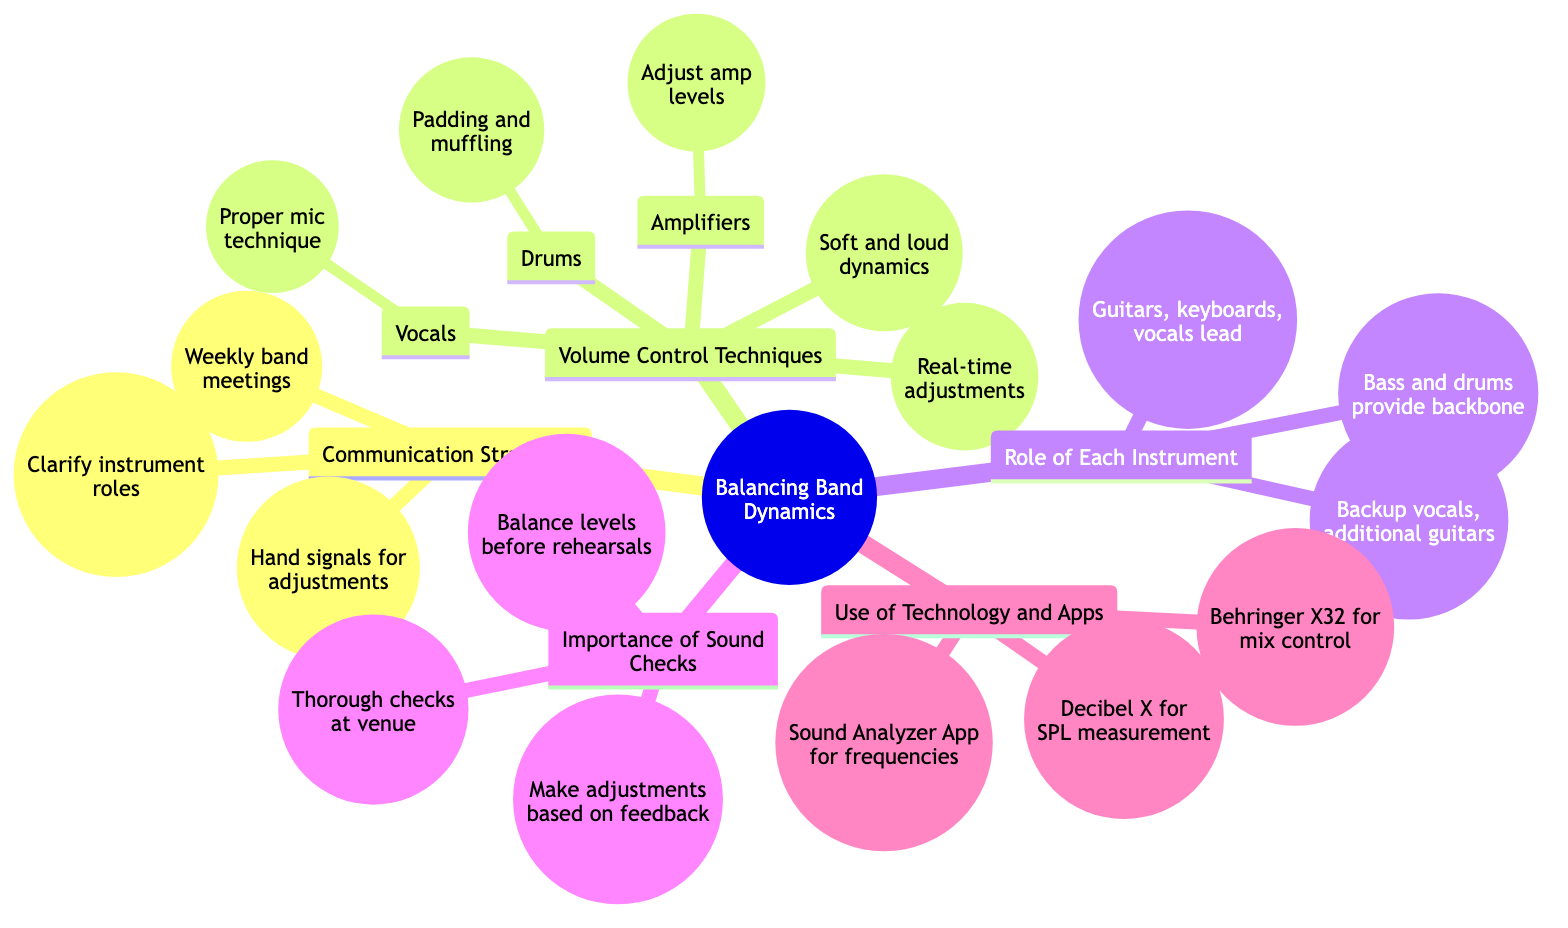What are the three main categories in the diagram? The main categories are 'Communication Strategies', 'Volume Control Techniques', 'Role of Each Instrument', 'Importance of Sound Checks', and 'Use of Technology and Apps'. Since the question asks for three, any three of the five will suffice.
Answer: Communication Strategies, Volume Control Techniques, Role of Each Instrument How many techniques are listed under Volume Control Techniques? Under 'Volume Control Techniques', there are four main techniques: 'Instrumental Adjustments', 'Use of Dynamics', 'Volume Pedals'. Therefore, the answer is three techniques.
Answer: 3 What is one method used for controlling drum volume? In the 'Instrumental Adjustments' section under 'Volume Control Techniques', 'Padding and muffling' is listed as a method for controlling drum volume.
Answer: Padding and muffling Which instrument is listed as part of the Rhythm Section? The 'Rhythm Section' includes 'Bass and drums' as part of its role in maintaining the groove.
Answer: Bass and drums What feedback mechanism is mentioned in the Importance of Sound Checks? The diagram mentions 'Feedback Loop' under 'Importance of Sound Checks', which indicates options for making adjustments based on sound checks.
Answer: Feedback Loop Name an app used for measuring sound pressure levels. Under 'Use of Technology and Apps for Volume Balancing', 'Decibel X' is mentioned as an app for measuring sound pressure levels.
Answer: Decibel X Which type of instruments typically take the lead in a band? In the 'Role of Each Instrument' category, 'Lead Instruments' is defined as including 'Guitars, keyboards, and vocals', indicating these typically take the lead.
Answer: Guitars, keyboards, and vocals What is the primary purpose of pre-rehearsal checks? According to the diagram, the primary purpose of 'Pre-Rehearsal Checks' is to 'Ensure each instrument's sound level is balanced before rehearsals'.
Answer: Ensure each instrument's sound level is balanced before rehearsals How many types of adjustments do we see listed under Instrumental Adjustments? Under 'Instrumental Adjustments', there are three types mentioned: 'Drums', 'Amplifiers', and 'Vocals', indicating three distinct types of adjustments for volume control.
Answer: 3 